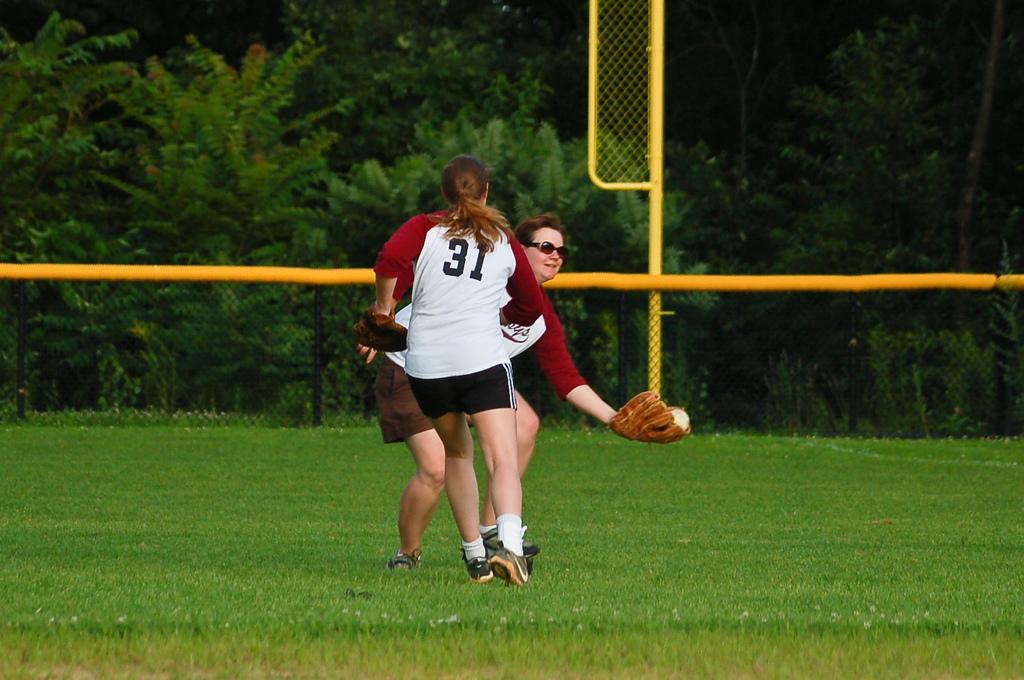Which player is about to touch the base?
Provide a succinct answer. 31. 